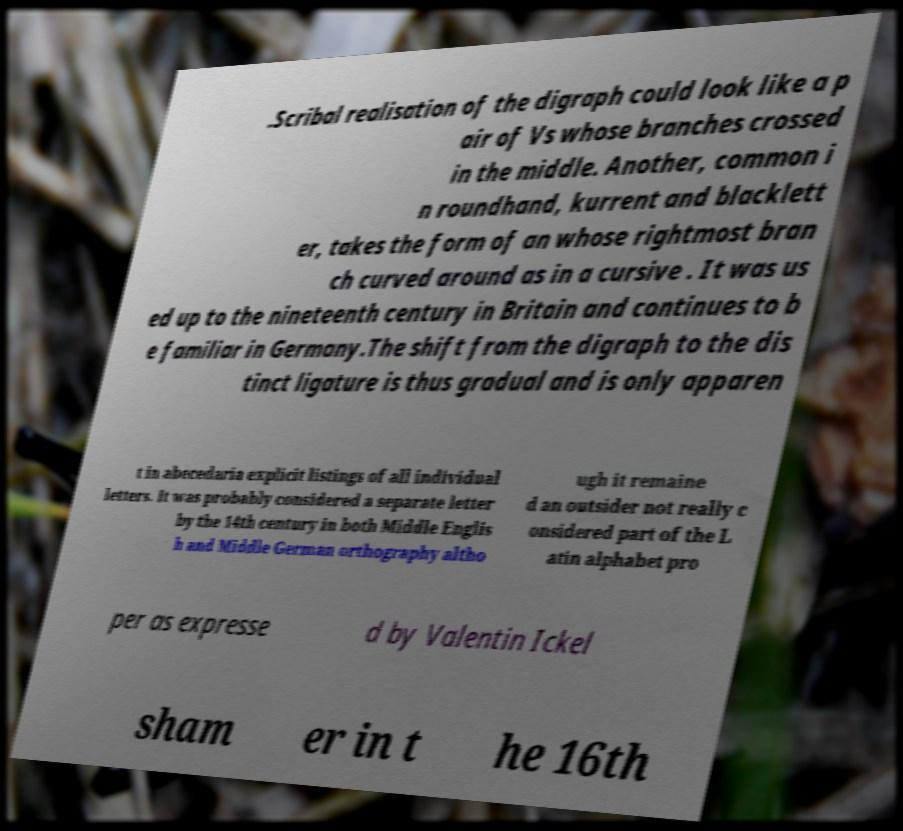Could you assist in decoding the text presented in this image and type it out clearly? .Scribal realisation of the digraph could look like a p air of Vs whose branches crossed in the middle. Another, common i n roundhand, kurrent and blacklett er, takes the form of an whose rightmost bran ch curved around as in a cursive . It was us ed up to the nineteenth century in Britain and continues to b e familiar in Germany.The shift from the digraph to the dis tinct ligature is thus gradual and is only apparen t in abecedaria explicit listings of all individual letters. It was probably considered a separate letter by the 14th century in both Middle Englis h and Middle German orthography altho ugh it remaine d an outsider not really c onsidered part of the L atin alphabet pro per as expresse d by Valentin Ickel sham er in t he 16th 